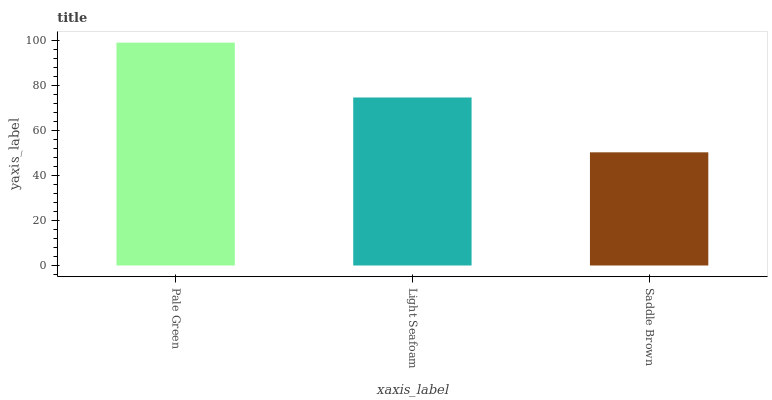Is Saddle Brown the minimum?
Answer yes or no. Yes. Is Pale Green the maximum?
Answer yes or no. Yes. Is Light Seafoam the minimum?
Answer yes or no. No. Is Light Seafoam the maximum?
Answer yes or no. No. Is Pale Green greater than Light Seafoam?
Answer yes or no. Yes. Is Light Seafoam less than Pale Green?
Answer yes or no. Yes. Is Light Seafoam greater than Pale Green?
Answer yes or no. No. Is Pale Green less than Light Seafoam?
Answer yes or no. No. Is Light Seafoam the high median?
Answer yes or no. Yes. Is Light Seafoam the low median?
Answer yes or no. Yes. Is Saddle Brown the high median?
Answer yes or no. No. Is Saddle Brown the low median?
Answer yes or no. No. 